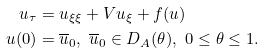<formula> <loc_0><loc_0><loc_500><loc_500>u _ { \tau } & = u _ { \xi \xi } + V u _ { \xi } + f ( u ) \\ u ( 0 ) & = \overline { u } _ { 0 } , \ \overline { u } _ { 0 } \in D _ { A } ( \theta ) , \ 0 \leq \theta \leq 1 .</formula> 